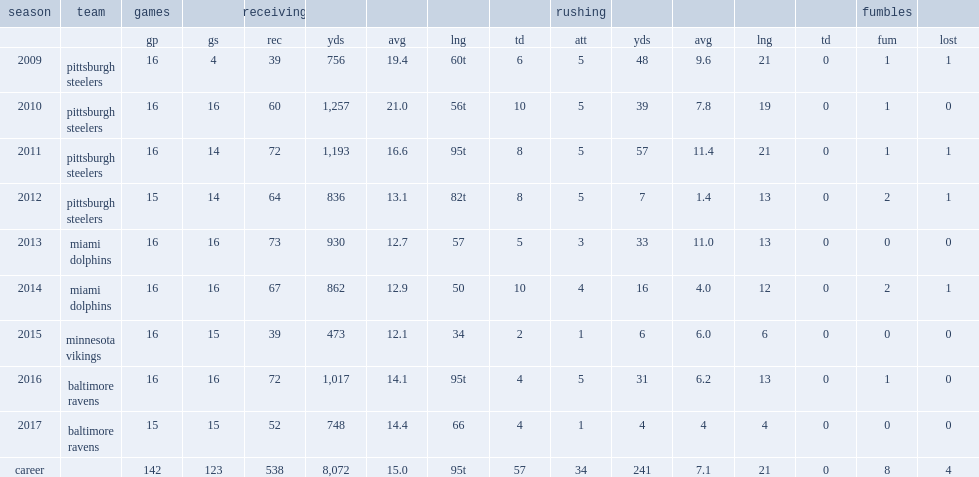In 2010, how many receiving yards did wallace have a standout second season with the steelers? 1257.0. In 2010, how many touchdowns did wallace have a standout second season with the steelers? 10.0. 